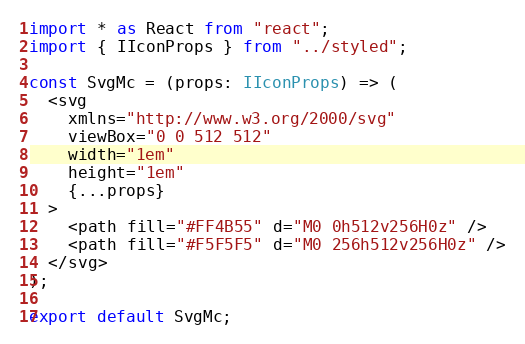<code> <loc_0><loc_0><loc_500><loc_500><_TypeScript_>import * as React from "react";
import { IIconProps } from "../styled";

const SvgMc = (props: IIconProps) => (
  <svg
    xmlns="http://www.w3.org/2000/svg"
    viewBox="0 0 512 512"
    width="1em"
    height="1em"
    {...props}
  >
    <path fill="#FF4B55" d="M0 0h512v256H0z" />
    <path fill="#F5F5F5" d="M0 256h512v256H0z" />
  </svg>
);

export default SvgMc;
</code> 